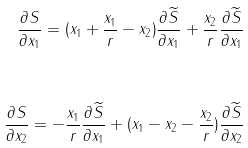<formula> <loc_0><loc_0><loc_500><loc_500>\frac { \partial S } { \partial x _ { 1 } } = ( x _ { 1 } + \frac { x _ { 1 } } { r } - x _ { 2 } ) \frac { \partial { \widetilde { S } } } { \partial x _ { 1 } } + \frac { x _ { 2 } } { r } \frac { \partial { \widetilde { S } } } { \partial x _ { 1 } } \\ \\ \frac { \partial S } { \partial x _ { 2 } } = - \frac { x _ { 1 } } { r } \frac { \partial { \widetilde { S } } } { \partial x _ { 1 } } + ( x _ { 1 } - x _ { 2 } - \frac { x _ { 2 } } { r } ) \frac { \partial { \widetilde { S } } } { \partial x _ { 2 } }</formula> 